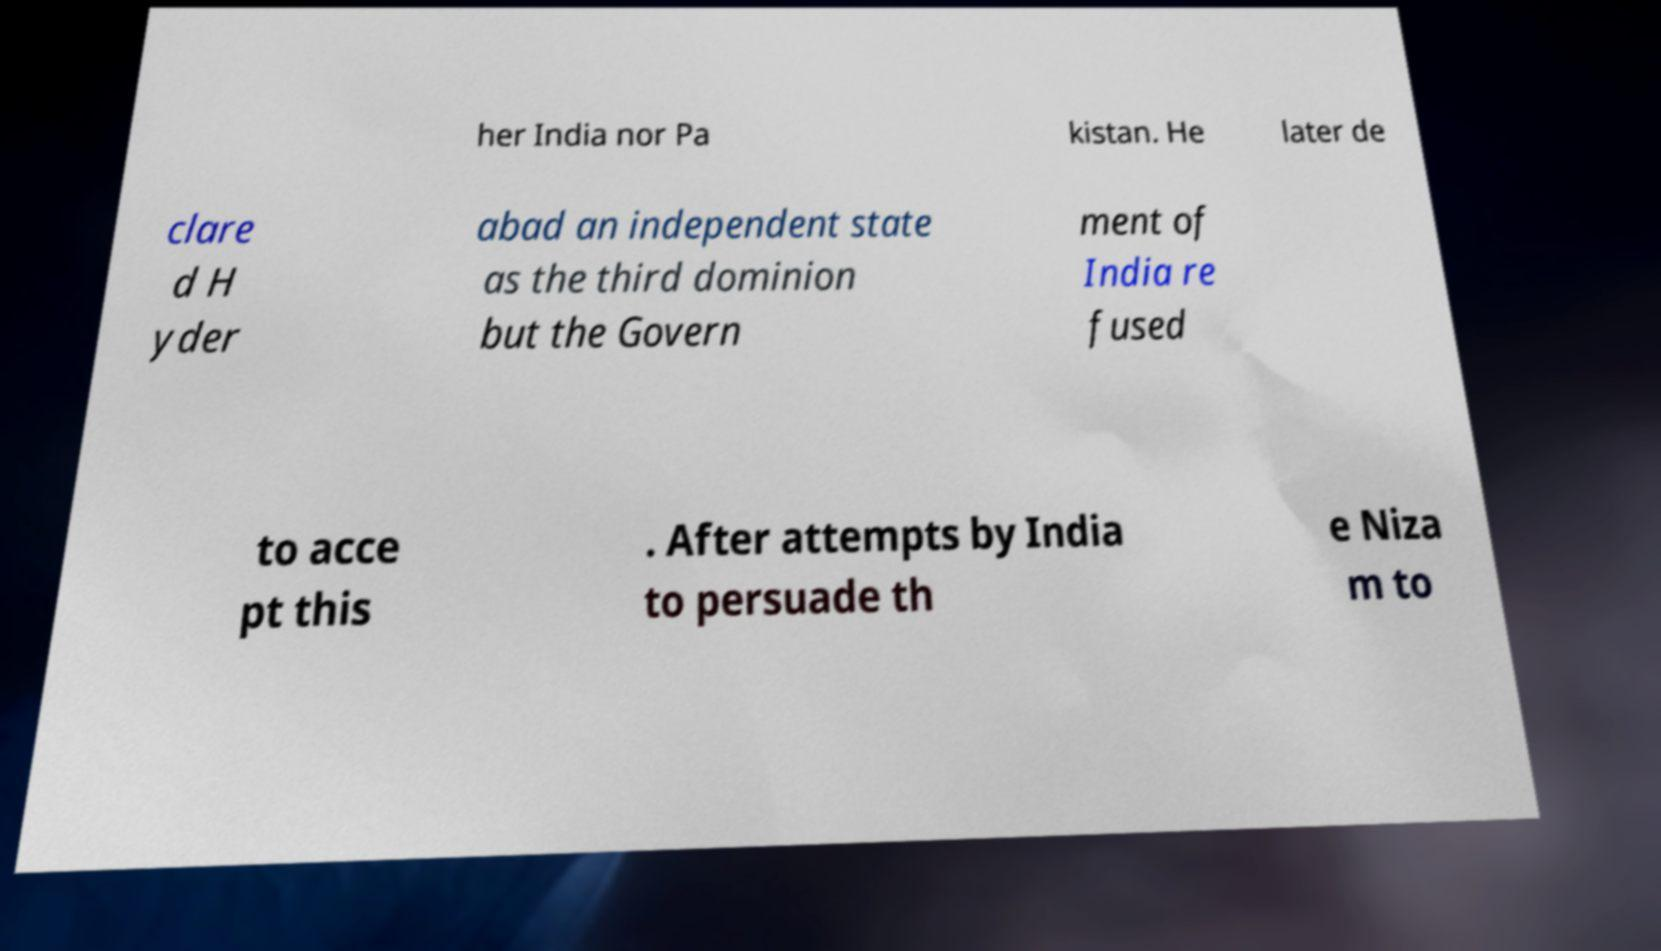Can you read and provide the text displayed in the image?This photo seems to have some interesting text. Can you extract and type it out for me? her India nor Pa kistan. He later de clare d H yder abad an independent state as the third dominion but the Govern ment of India re fused to acce pt this . After attempts by India to persuade th e Niza m to 